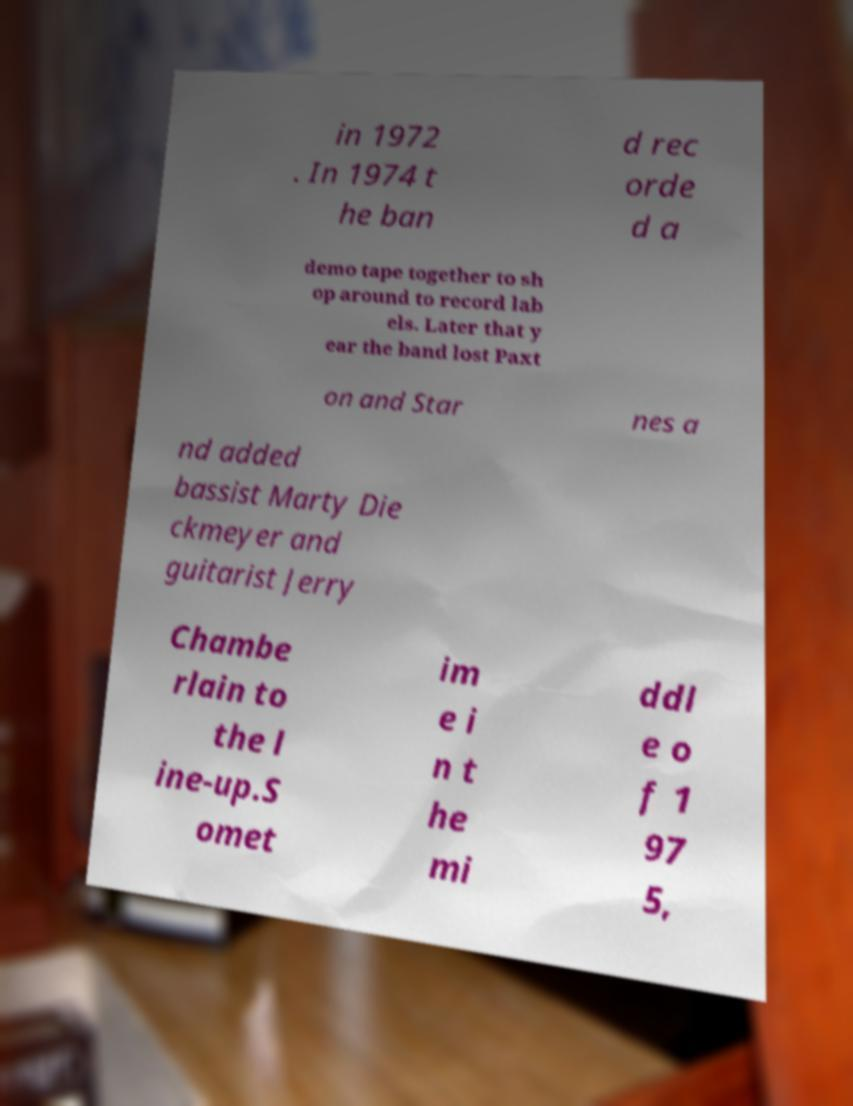Could you assist in decoding the text presented in this image and type it out clearly? in 1972 . In 1974 t he ban d rec orde d a demo tape together to sh op around to record lab els. Later that y ear the band lost Paxt on and Star nes a nd added bassist Marty Die ckmeyer and guitarist Jerry Chambe rlain to the l ine-up.S omet im e i n t he mi ddl e o f 1 97 5, 